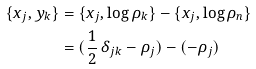<formula> <loc_0><loc_0><loc_500><loc_500>\{ x _ { j } , y _ { k } \} & = \{ x _ { j } , \log \rho _ { k } \} - \{ x _ { j } , \log \rho _ { n } \} \\ & = ( \frac { 1 } { 2 } \, \delta _ { j k } - \rho _ { j } ) - ( - \rho _ { j } )</formula> 